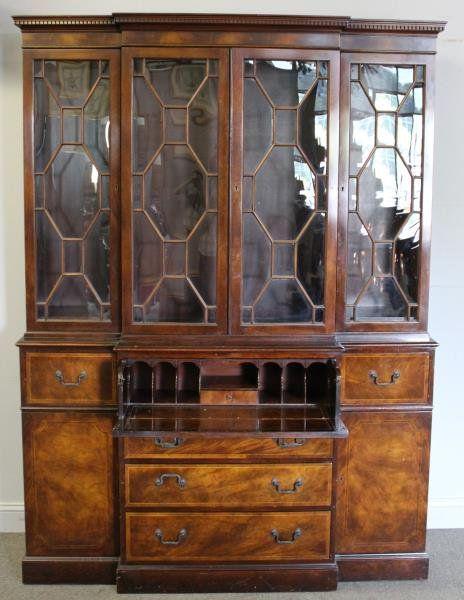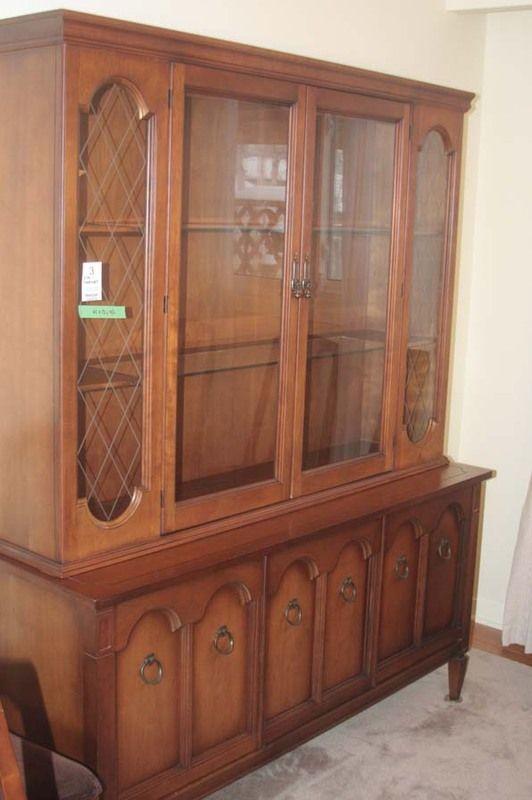The first image is the image on the left, the second image is the image on the right. Given the left and right images, does the statement "At least one of the cabinets has no legs and sits flush on the floor." hold true? Answer yes or no. Yes. The first image is the image on the left, the second image is the image on the right. Analyze the images presented: Is the assertion "There are three vertically stacked drawers in the image on the left." valid? Answer yes or no. Yes. 